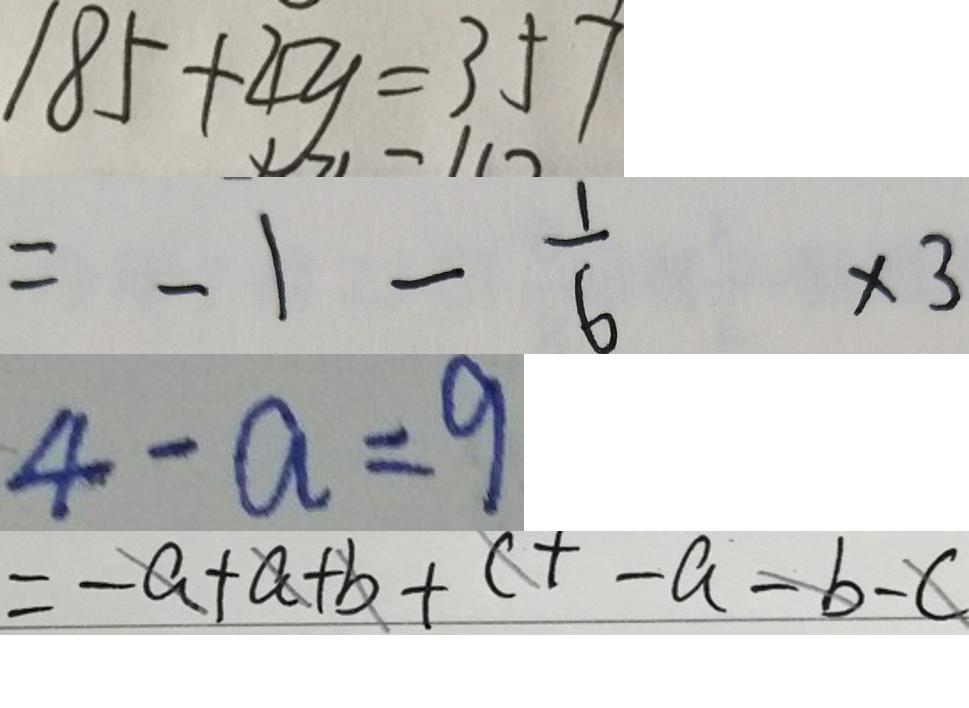<formula> <loc_0><loc_0><loc_500><loc_500>1 8 5 + 4 y = 3 5 7 
 = - 1 - \frac { 1 } { 6 } \times 3 
 4 - a = 9 
 = - a + a + b + c + - a - b - c</formula> 